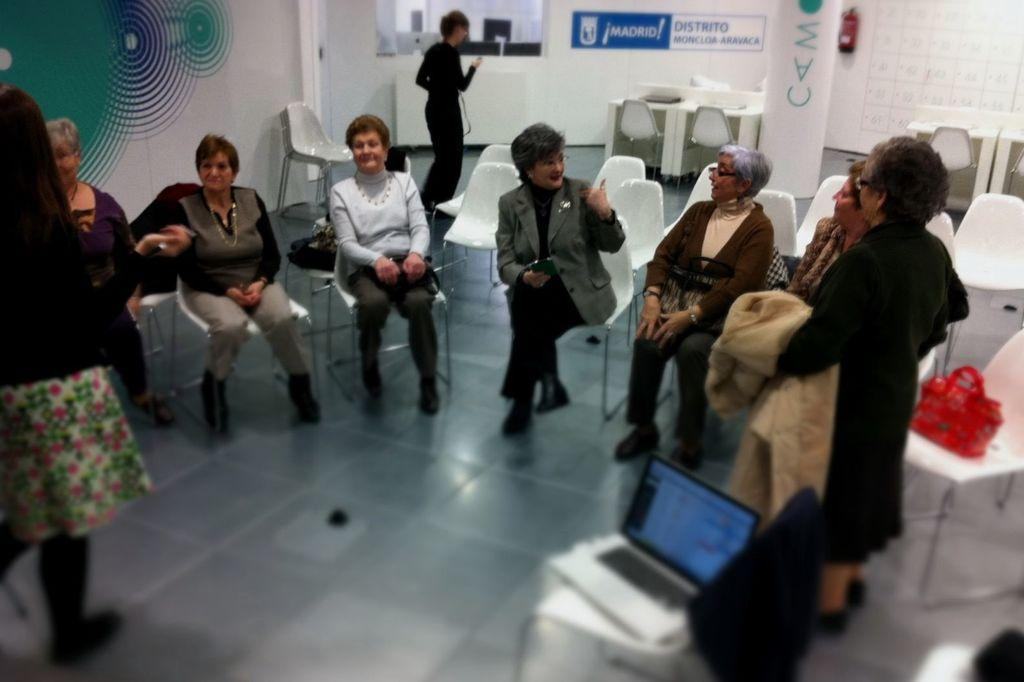What is the main subject of the image? The main subject of the image is a group of women. What are the women doing in the image? The women are sitting in chairs and talking among themselves. What type of word can be seen on the shirt of one of the women in the image? There is no word visible on the shirt of any of the women in the image. How many cattle are present in the image? There are no cattle present in the image; it features a group of women sitting and talking. 